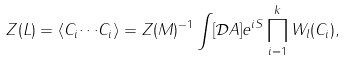Convert formula to latex. <formula><loc_0><loc_0><loc_500><loc_500>Z ( L ) = \langle { C _ { i } { \cdots } C _ { i } } \rangle = Z { ( M ) } ^ { - 1 } \int [ { \mathcal { D } } A ] { e ^ { i S } } \prod _ { i = 1 } ^ { k } W _ { l } ( C _ { i } ) ,</formula> 